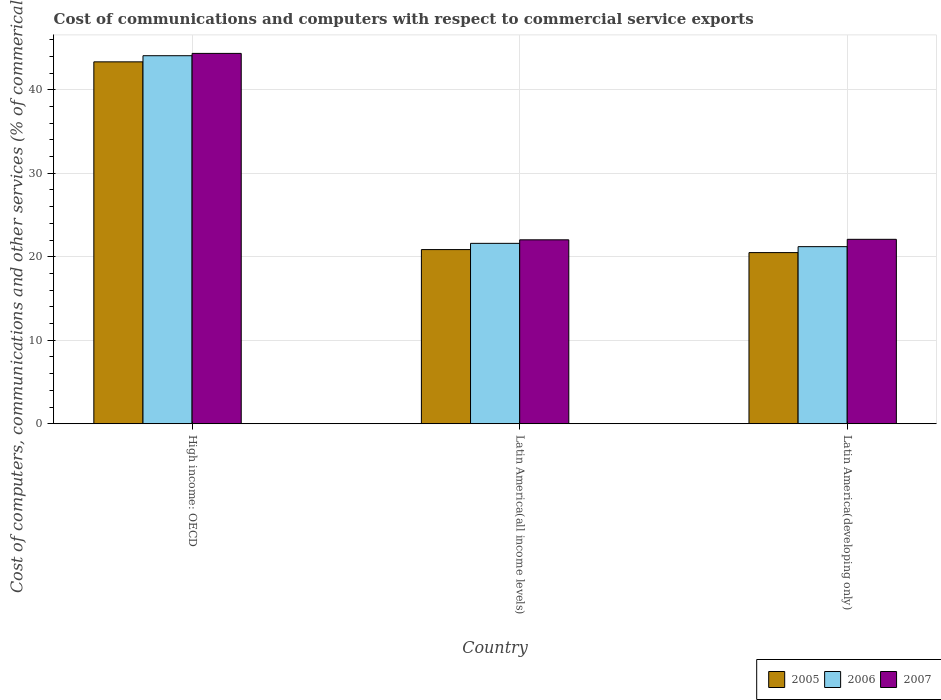How many different coloured bars are there?
Give a very brief answer. 3. How many groups of bars are there?
Keep it short and to the point. 3. Are the number of bars on each tick of the X-axis equal?
Your answer should be compact. Yes. What is the label of the 2nd group of bars from the left?
Your response must be concise. Latin America(all income levels). In how many cases, is the number of bars for a given country not equal to the number of legend labels?
Give a very brief answer. 0. What is the cost of communications and computers in 2007 in High income: OECD?
Your response must be concise. 44.35. Across all countries, what is the maximum cost of communications and computers in 2007?
Your answer should be very brief. 44.35. Across all countries, what is the minimum cost of communications and computers in 2005?
Ensure brevity in your answer.  20.49. In which country was the cost of communications and computers in 2005 maximum?
Make the answer very short. High income: OECD. In which country was the cost of communications and computers in 2007 minimum?
Your response must be concise. Latin America(all income levels). What is the total cost of communications and computers in 2006 in the graph?
Provide a short and direct response. 86.88. What is the difference between the cost of communications and computers in 2006 in High income: OECD and that in Latin America(all income levels)?
Give a very brief answer. 22.47. What is the difference between the cost of communications and computers in 2006 in Latin America(all income levels) and the cost of communications and computers in 2005 in Latin America(developing only)?
Provide a succinct answer. 1.11. What is the average cost of communications and computers in 2005 per country?
Your response must be concise. 28.23. What is the difference between the cost of communications and computers of/in 2005 and cost of communications and computers of/in 2007 in Latin America(developing only)?
Your answer should be compact. -1.59. What is the ratio of the cost of communications and computers in 2005 in High income: OECD to that in Latin America(all income levels)?
Offer a terse response. 2.08. Is the cost of communications and computers in 2005 in High income: OECD less than that in Latin America(all income levels)?
Your answer should be very brief. No. What is the difference between the highest and the second highest cost of communications and computers in 2006?
Provide a short and direct response. -22.87. What is the difference between the highest and the lowest cost of communications and computers in 2007?
Your answer should be compact. 22.33. What does the 3rd bar from the left in High income: OECD represents?
Offer a very short reply. 2007. Are all the bars in the graph horizontal?
Ensure brevity in your answer.  No. Does the graph contain grids?
Keep it short and to the point. Yes. How many legend labels are there?
Your response must be concise. 3. What is the title of the graph?
Offer a very short reply. Cost of communications and computers with respect to commercial service exports. Does "1962" appear as one of the legend labels in the graph?
Provide a short and direct response. No. What is the label or title of the X-axis?
Offer a very short reply. Country. What is the label or title of the Y-axis?
Offer a very short reply. Cost of computers, communications and other services (% of commerical service exports). What is the Cost of computers, communications and other services (% of commerical service exports) in 2005 in High income: OECD?
Make the answer very short. 43.34. What is the Cost of computers, communications and other services (% of commerical service exports) in 2006 in High income: OECD?
Offer a very short reply. 44.07. What is the Cost of computers, communications and other services (% of commerical service exports) in 2007 in High income: OECD?
Give a very brief answer. 44.35. What is the Cost of computers, communications and other services (% of commerical service exports) of 2005 in Latin America(all income levels)?
Offer a very short reply. 20.86. What is the Cost of computers, communications and other services (% of commerical service exports) in 2006 in Latin America(all income levels)?
Give a very brief answer. 21.6. What is the Cost of computers, communications and other services (% of commerical service exports) in 2007 in Latin America(all income levels)?
Your answer should be very brief. 22.02. What is the Cost of computers, communications and other services (% of commerical service exports) of 2005 in Latin America(developing only)?
Ensure brevity in your answer.  20.49. What is the Cost of computers, communications and other services (% of commerical service exports) in 2006 in Latin America(developing only)?
Offer a terse response. 21.21. What is the Cost of computers, communications and other services (% of commerical service exports) in 2007 in Latin America(developing only)?
Your response must be concise. 22.09. Across all countries, what is the maximum Cost of computers, communications and other services (% of commerical service exports) of 2005?
Keep it short and to the point. 43.34. Across all countries, what is the maximum Cost of computers, communications and other services (% of commerical service exports) in 2006?
Your answer should be very brief. 44.07. Across all countries, what is the maximum Cost of computers, communications and other services (% of commerical service exports) in 2007?
Offer a very short reply. 44.35. Across all countries, what is the minimum Cost of computers, communications and other services (% of commerical service exports) in 2005?
Provide a succinct answer. 20.49. Across all countries, what is the minimum Cost of computers, communications and other services (% of commerical service exports) of 2006?
Keep it short and to the point. 21.21. Across all countries, what is the minimum Cost of computers, communications and other services (% of commerical service exports) of 2007?
Your answer should be very brief. 22.02. What is the total Cost of computers, communications and other services (% of commerical service exports) in 2005 in the graph?
Your answer should be very brief. 84.69. What is the total Cost of computers, communications and other services (% of commerical service exports) of 2006 in the graph?
Keep it short and to the point. 86.88. What is the total Cost of computers, communications and other services (% of commerical service exports) of 2007 in the graph?
Provide a succinct answer. 88.46. What is the difference between the Cost of computers, communications and other services (% of commerical service exports) in 2005 in High income: OECD and that in Latin America(all income levels)?
Your answer should be compact. 22.48. What is the difference between the Cost of computers, communications and other services (% of commerical service exports) in 2006 in High income: OECD and that in Latin America(all income levels)?
Provide a short and direct response. 22.47. What is the difference between the Cost of computers, communications and other services (% of commerical service exports) in 2007 in High income: OECD and that in Latin America(all income levels)?
Your answer should be very brief. 22.33. What is the difference between the Cost of computers, communications and other services (% of commerical service exports) in 2005 in High income: OECD and that in Latin America(developing only)?
Keep it short and to the point. 22.84. What is the difference between the Cost of computers, communications and other services (% of commerical service exports) of 2006 in High income: OECD and that in Latin America(developing only)?
Your answer should be compact. 22.87. What is the difference between the Cost of computers, communications and other services (% of commerical service exports) of 2007 in High income: OECD and that in Latin America(developing only)?
Give a very brief answer. 22.27. What is the difference between the Cost of computers, communications and other services (% of commerical service exports) in 2005 in Latin America(all income levels) and that in Latin America(developing only)?
Provide a succinct answer. 0.36. What is the difference between the Cost of computers, communications and other services (% of commerical service exports) of 2006 in Latin America(all income levels) and that in Latin America(developing only)?
Keep it short and to the point. 0.4. What is the difference between the Cost of computers, communications and other services (% of commerical service exports) in 2007 in Latin America(all income levels) and that in Latin America(developing only)?
Offer a very short reply. -0.06. What is the difference between the Cost of computers, communications and other services (% of commerical service exports) in 2005 in High income: OECD and the Cost of computers, communications and other services (% of commerical service exports) in 2006 in Latin America(all income levels)?
Give a very brief answer. 21.74. What is the difference between the Cost of computers, communications and other services (% of commerical service exports) in 2005 in High income: OECD and the Cost of computers, communications and other services (% of commerical service exports) in 2007 in Latin America(all income levels)?
Ensure brevity in your answer.  21.31. What is the difference between the Cost of computers, communications and other services (% of commerical service exports) in 2006 in High income: OECD and the Cost of computers, communications and other services (% of commerical service exports) in 2007 in Latin America(all income levels)?
Your answer should be compact. 22.05. What is the difference between the Cost of computers, communications and other services (% of commerical service exports) in 2005 in High income: OECD and the Cost of computers, communications and other services (% of commerical service exports) in 2006 in Latin America(developing only)?
Ensure brevity in your answer.  22.13. What is the difference between the Cost of computers, communications and other services (% of commerical service exports) in 2005 in High income: OECD and the Cost of computers, communications and other services (% of commerical service exports) in 2007 in Latin America(developing only)?
Ensure brevity in your answer.  21.25. What is the difference between the Cost of computers, communications and other services (% of commerical service exports) of 2006 in High income: OECD and the Cost of computers, communications and other services (% of commerical service exports) of 2007 in Latin America(developing only)?
Your answer should be very brief. 21.99. What is the difference between the Cost of computers, communications and other services (% of commerical service exports) in 2005 in Latin America(all income levels) and the Cost of computers, communications and other services (% of commerical service exports) in 2006 in Latin America(developing only)?
Offer a very short reply. -0.35. What is the difference between the Cost of computers, communications and other services (% of commerical service exports) of 2005 in Latin America(all income levels) and the Cost of computers, communications and other services (% of commerical service exports) of 2007 in Latin America(developing only)?
Provide a succinct answer. -1.23. What is the difference between the Cost of computers, communications and other services (% of commerical service exports) in 2006 in Latin America(all income levels) and the Cost of computers, communications and other services (% of commerical service exports) in 2007 in Latin America(developing only)?
Offer a very short reply. -0.48. What is the average Cost of computers, communications and other services (% of commerical service exports) of 2005 per country?
Keep it short and to the point. 28.23. What is the average Cost of computers, communications and other services (% of commerical service exports) of 2006 per country?
Make the answer very short. 28.96. What is the average Cost of computers, communications and other services (% of commerical service exports) of 2007 per country?
Give a very brief answer. 29.49. What is the difference between the Cost of computers, communications and other services (% of commerical service exports) of 2005 and Cost of computers, communications and other services (% of commerical service exports) of 2006 in High income: OECD?
Your answer should be compact. -0.74. What is the difference between the Cost of computers, communications and other services (% of commerical service exports) in 2005 and Cost of computers, communications and other services (% of commerical service exports) in 2007 in High income: OECD?
Make the answer very short. -1.01. What is the difference between the Cost of computers, communications and other services (% of commerical service exports) in 2006 and Cost of computers, communications and other services (% of commerical service exports) in 2007 in High income: OECD?
Offer a terse response. -0.28. What is the difference between the Cost of computers, communications and other services (% of commerical service exports) in 2005 and Cost of computers, communications and other services (% of commerical service exports) in 2006 in Latin America(all income levels)?
Provide a succinct answer. -0.75. What is the difference between the Cost of computers, communications and other services (% of commerical service exports) of 2005 and Cost of computers, communications and other services (% of commerical service exports) of 2007 in Latin America(all income levels)?
Give a very brief answer. -1.17. What is the difference between the Cost of computers, communications and other services (% of commerical service exports) in 2006 and Cost of computers, communications and other services (% of commerical service exports) in 2007 in Latin America(all income levels)?
Your answer should be very brief. -0.42. What is the difference between the Cost of computers, communications and other services (% of commerical service exports) in 2005 and Cost of computers, communications and other services (% of commerical service exports) in 2006 in Latin America(developing only)?
Offer a very short reply. -0.71. What is the difference between the Cost of computers, communications and other services (% of commerical service exports) in 2005 and Cost of computers, communications and other services (% of commerical service exports) in 2007 in Latin America(developing only)?
Your answer should be compact. -1.59. What is the difference between the Cost of computers, communications and other services (% of commerical service exports) in 2006 and Cost of computers, communications and other services (% of commerical service exports) in 2007 in Latin America(developing only)?
Give a very brief answer. -0.88. What is the ratio of the Cost of computers, communications and other services (% of commerical service exports) of 2005 in High income: OECD to that in Latin America(all income levels)?
Your answer should be compact. 2.08. What is the ratio of the Cost of computers, communications and other services (% of commerical service exports) in 2006 in High income: OECD to that in Latin America(all income levels)?
Ensure brevity in your answer.  2.04. What is the ratio of the Cost of computers, communications and other services (% of commerical service exports) of 2007 in High income: OECD to that in Latin America(all income levels)?
Provide a short and direct response. 2.01. What is the ratio of the Cost of computers, communications and other services (% of commerical service exports) of 2005 in High income: OECD to that in Latin America(developing only)?
Your answer should be very brief. 2.11. What is the ratio of the Cost of computers, communications and other services (% of commerical service exports) in 2006 in High income: OECD to that in Latin America(developing only)?
Make the answer very short. 2.08. What is the ratio of the Cost of computers, communications and other services (% of commerical service exports) of 2007 in High income: OECD to that in Latin America(developing only)?
Offer a terse response. 2.01. What is the ratio of the Cost of computers, communications and other services (% of commerical service exports) in 2005 in Latin America(all income levels) to that in Latin America(developing only)?
Offer a terse response. 1.02. What is the ratio of the Cost of computers, communications and other services (% of commerical service exports) in 2006 in Latin America(all income levels) to that in Latin America(developing only)?
Provide a succinct answer. 1.02. What is the difference between the highest and the second highest Cost of computers, communications and other services (% of commerical service exports) in 2005?
Keep it short and to the point. 22.48. What is the difference between the highest and the second highest Cost of computers, communications and other services (% of commerical service exports) in 2006?
Keep it short and to the point. 22.47. What is the difference between the highest and the second highest Cost of computers, communications and other services (% of commerical service exports) of 2007?
Your answer should be very brief. 22.27. What is the difference between the highest and the lowest Cost of computers, communications and other services (% of commerical service exports) of 2005?
Provide a succinct answer. 22.84. What is the difference between the highest and the lowest Cost of computers, communications and other services (% of commerical service exports) in 2006?
Ensure brevity in your answer.  22.87. What is the difference between the highest and the lowest Cost of computers, communications and other services (% of commerical service exports) of 2007?
Your response must be concise. 22.33. 